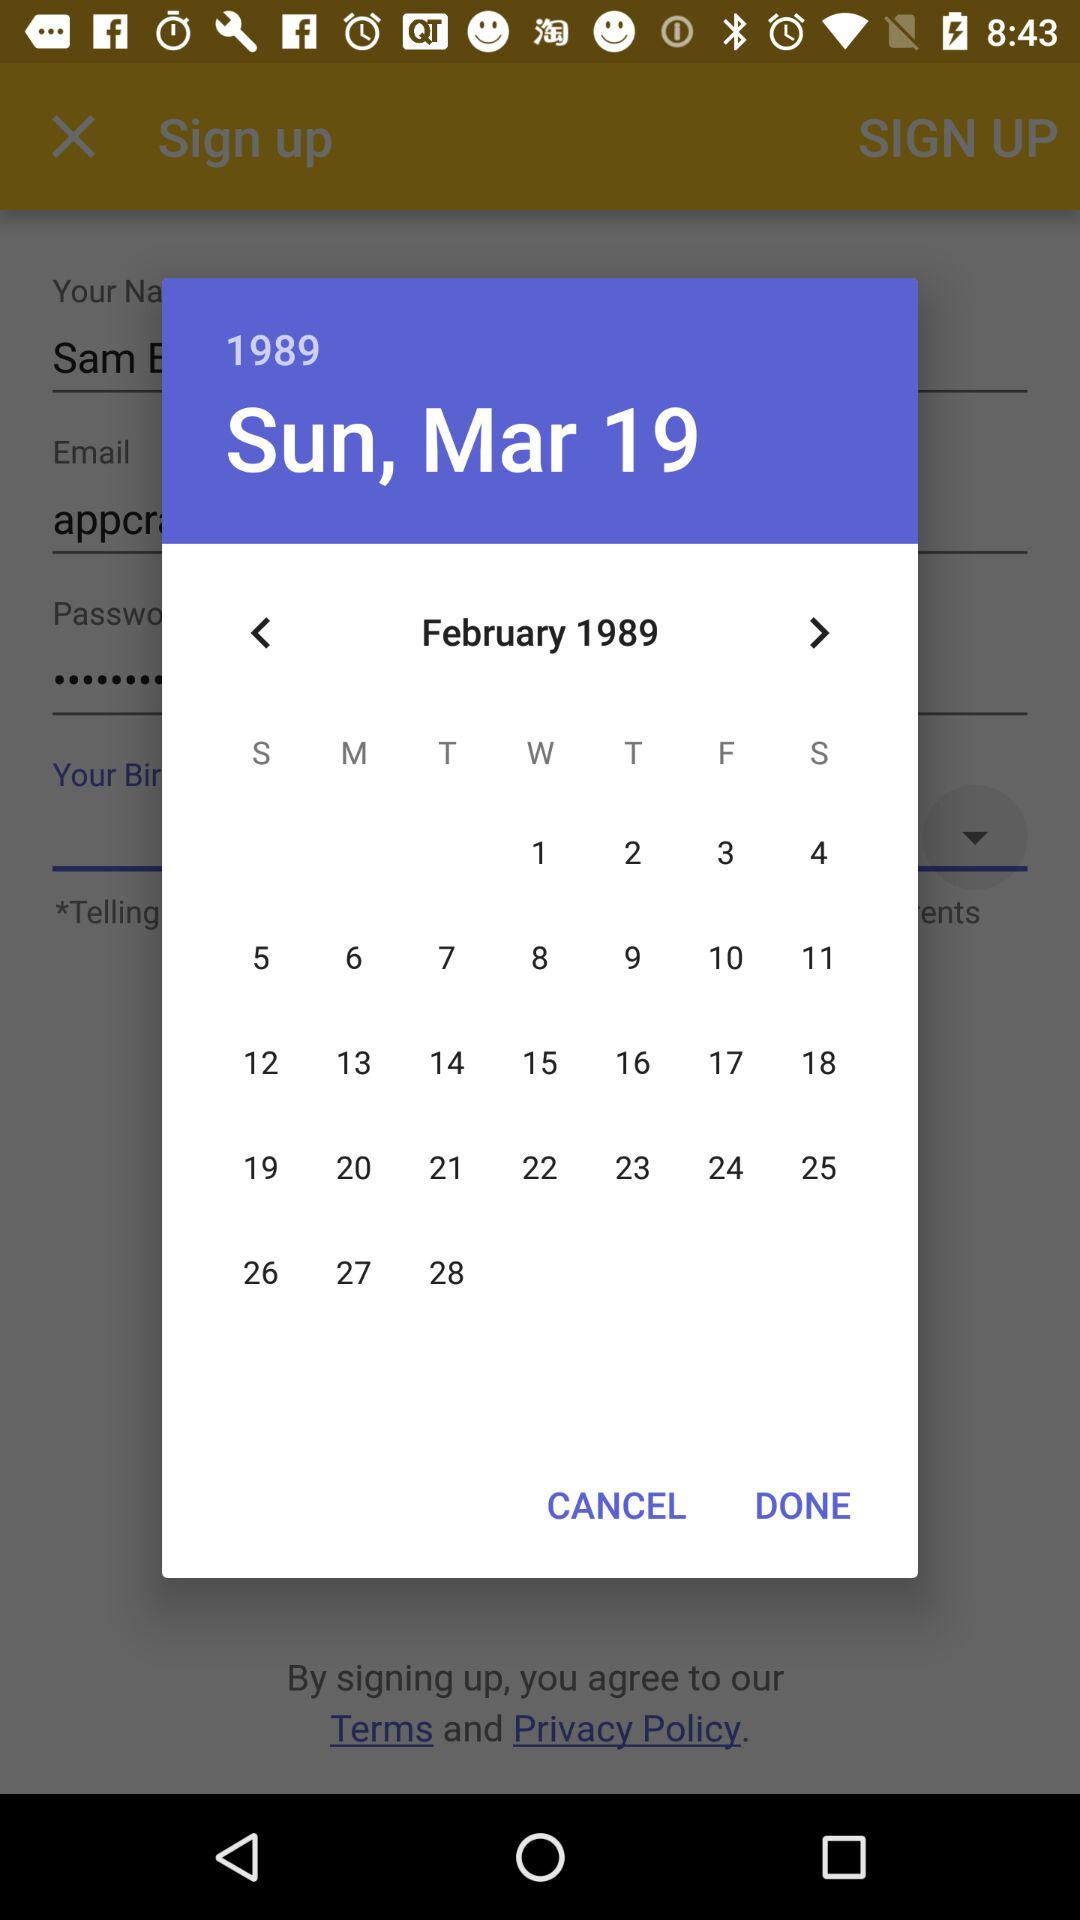What is the user's surname?
When the provided information is insufficient, respond with <no answer>. <no answer> 